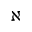<formula> <loc_0><loc_0><loc_500><loc_500>\aleph</formula> 